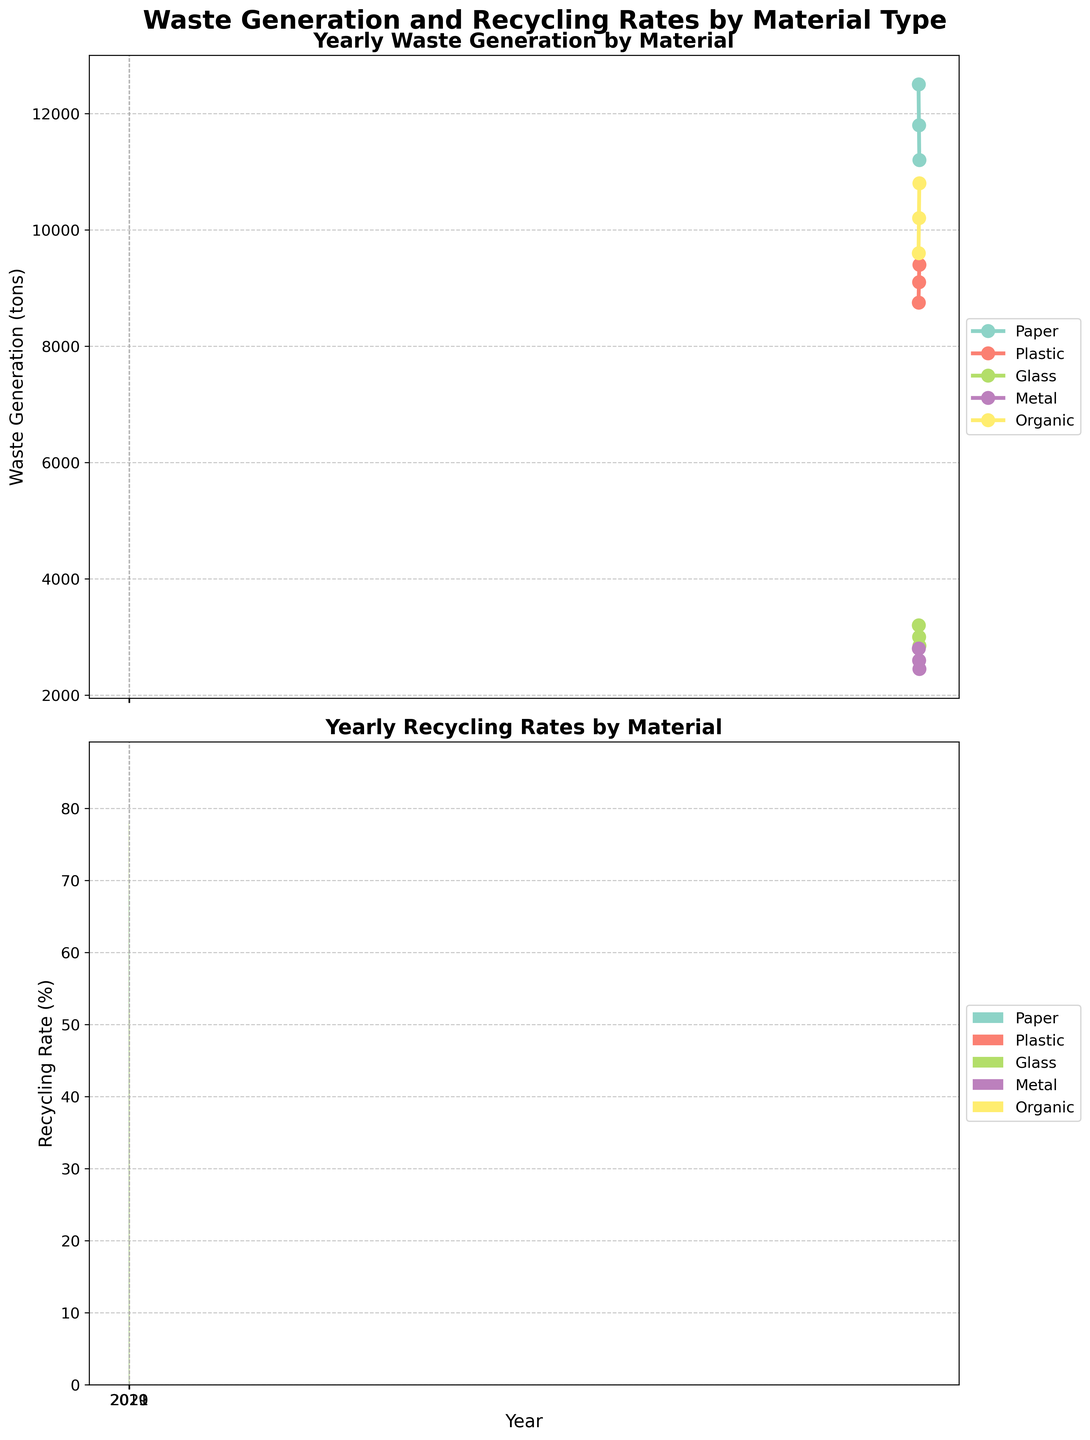What is the title of the figure? The title of the figure is usually found at the top and provides an overview of the information displayed. It helps the viewer immediately understand the context of the visualized data.
Answer: Waste Generation and Recycling Rates by Material Type Which material had the highest recycling rate in 2019? To find this, look at the bars in the second subplot for the year 2019 and identify the material with the tallest bar.
Answer: Metal How did the waste generation for paper change from 2019 to 2021? First, find the waste generation values for paper for each year on the line plot in the first subplot. Then, compare the values for 2019 and 2021.
Answer: Decreased Which year had the highest total waste generation for organic material? Look at the line plot for organic material (green line) in the first subplot and find the year with the highest data point.
Answer: 2021 Compare the recycling rates of plastic and glass in 2020. Which is higher? In the bar chart for 2020, identify the bars corresponding to plastic and glass and compare their heights.
Answer: Glass What is the trend of metal waste generation over the years? Observe the line representing metal in the first subplot, noting how the values change from 2019 to 2021.
Answer: Decreasing Which material saw the most significant increase in recycling rate from 2019 to 2021? Look at the bars in the second subplot for each material and compare the recycling rates from 2019 to 2021. Identify the material with the largest increase in bar height.
Answer: Organic How do the recycling rates for paper and organic materials compare in 2021? Look at the bars for paper and organic materials in the second subplot for 2021 and compare their heights.
Answer: Paper has a higher recycling rate What was the waste generation for plastic in 2020? Locate the point for plastic in the line plot for the year 2020 and read the corresponding waste generation value.
Answer: 9100 tons Between the materials listed, which had the least variation in waste generation over the years? Look at the line plots in the first subplot and observe which line remains the most horizontal or has the smallest changes across the years.
Answer: Metal 